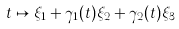Convert formula to latex. <formula><loc_0><loc_0><loc_500><loc_500>t \mapsto \xi _ { 1 } + \gamma _ { 1 } ( t ) \xi _ { 2 } + \gamma _ { 2 } ( t ) \xi _ { 3 }</formula> 